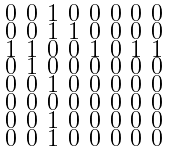<formula> <loc_0><loc_0><loc_500><loc_500>\begin{smallmatrix} 0 & 0 & 1 & 0 & 0 & 0 & 0 & 0 \\ 0 & 0 & 1 & 1 & 0 & 0 & 0 & 0 \\ 1 & 1 & 0 & 0 & 1 & 0 & 1 & 1 \\ 0 & 1 & 0 & 0 & 0 & 0 & 0 & 0 \\ 0 & 0 & 1 & 0 & 0 & 0 & 0 & 0 \\ 0 & 0 & 0 & 0 & 0 & 0 & 0 & 0 \\ 0 & 0 & 1 & 0 & 0 & 0 & 0 & 0 \\ 0 & 0 & 1 & 0 & 0 & 0 & 0 & 0 \end{smallmatrix}</formula> 